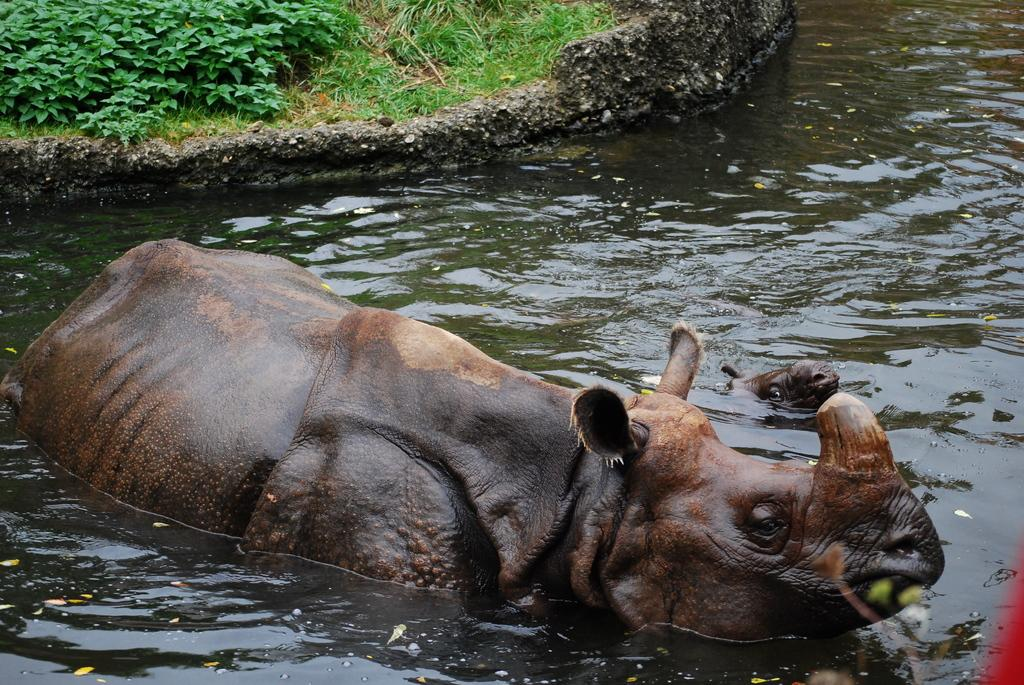What animal is in the water in the image? There is a rhinoceros in the water in the image. What is the color of the water? The water is green in color. What can be seen behind the rhinoceros? There is a path with grass behind the rhinoceros. What type of vegetation is visible near the path? There are plants visible near the path. What type of window can be seen on the stage in the image? There is no window or stage present in the image; it features a rhinoceros in green water with a grassy path and plants nearby. 